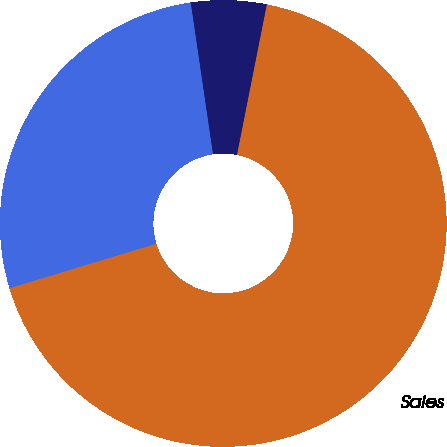<chart> <loc_0><loc_0><loc_500><loc_500><pie_chart><fcel>In millions<fcel>Sales<fcel>Operating Profit<nl><fcel>27.37%<fcel>67.19%<fcel>5.44%<nl></chart> 